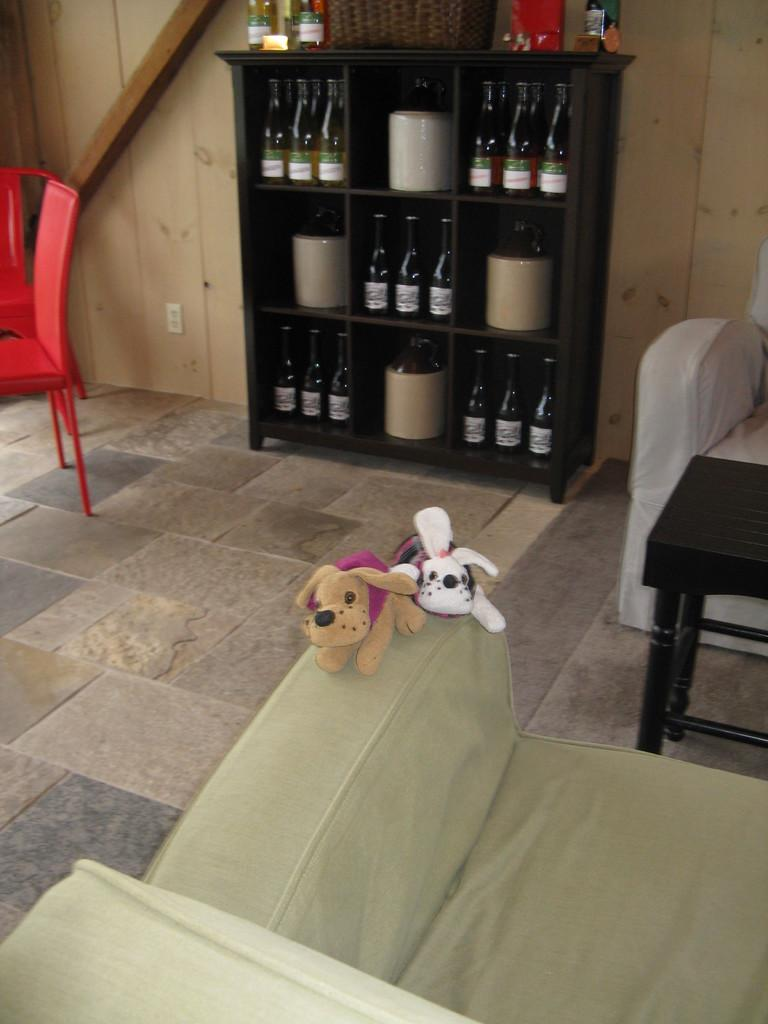What type of stuffed animals are on the sofa in the image? There are teddy bears on the sofa in the image. What can be seen on the shelves on the wall? There are shelves with wine bottles on the wall. How many chairs are visible in the image? There are chairs on both the right and left sides of the room. Where is the kettle located in the image? There is no kettle present in the image. What type of border is visible in the image? There is no border visible in the image. 